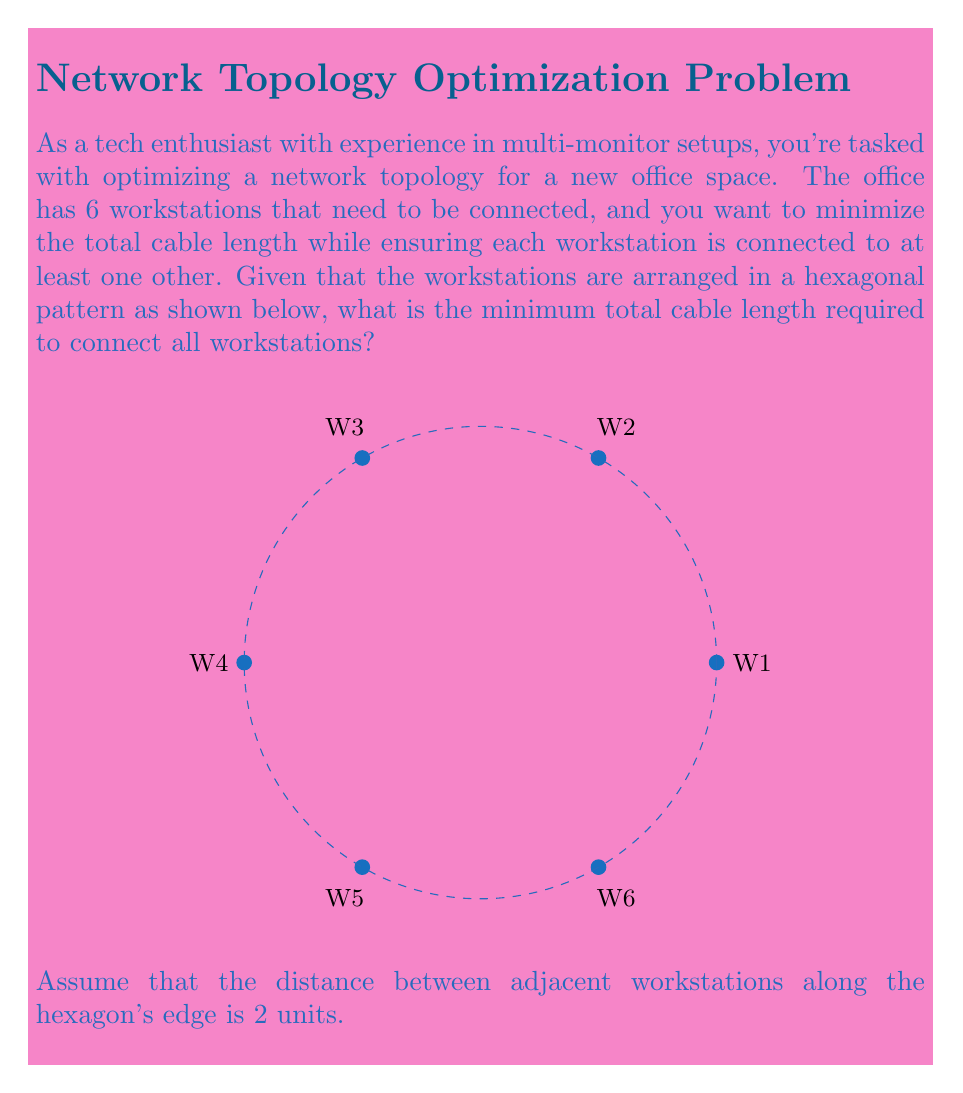Provide a solution to this math problem. Let's approach this step-by-step:

1) First, we need to recognize that the optimal arrangement for minimizing total cable length is a spanning tree. In this case, it will be a minimum spanning tree (MST).

2) For a hexagonal arrangement, the MST will connect each workstation to its two adjacent workstations, except for one edge of the hexagon.

3) To calculate the total cable length, we need to know the length of each edge of the hexagon. Given that the distance between adjacent workstations is 2 units, this is our edge length.

4) In a minimum spanning tree for this configuration, we'll use 5 edges to connect all 6 workstations.

5) Therefore, the total cable length will be:

   $$\text{Total Length} = 5 \times 2 = 10 \text{ units}$$

6) We can verify this is optimal because:
   - Using fewer than 5 edges would leave some workstations disconnected.
   - Using more than 5 edges would create loops and increase total length unnecessarily.
   - Any other arrangement of 5 edges would either disconnect some workstations or increase the total length.

This solution effectively creates a chain of workstations around the hexagon, leaving one edge unconnected, which is the optimal arrangement for this topology.
Answer: 10 units 